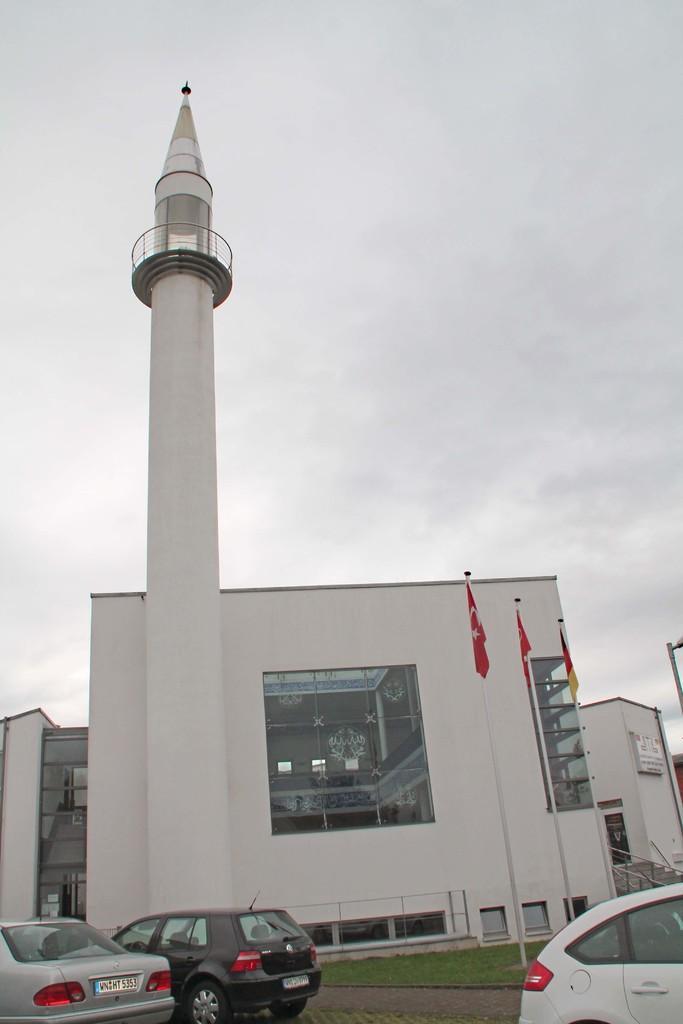Describe this image in one or two sentences. In the foreground of the image we can see group of vehicles parked on the road. In the center of the image we can see a building with a tower. To the right side of the image we can see star case, three flags on poles and in the background we can see the sky. 